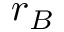<formula> <loc_0><loc_0><loc_500><loc_500>r _ { B }</formula> 